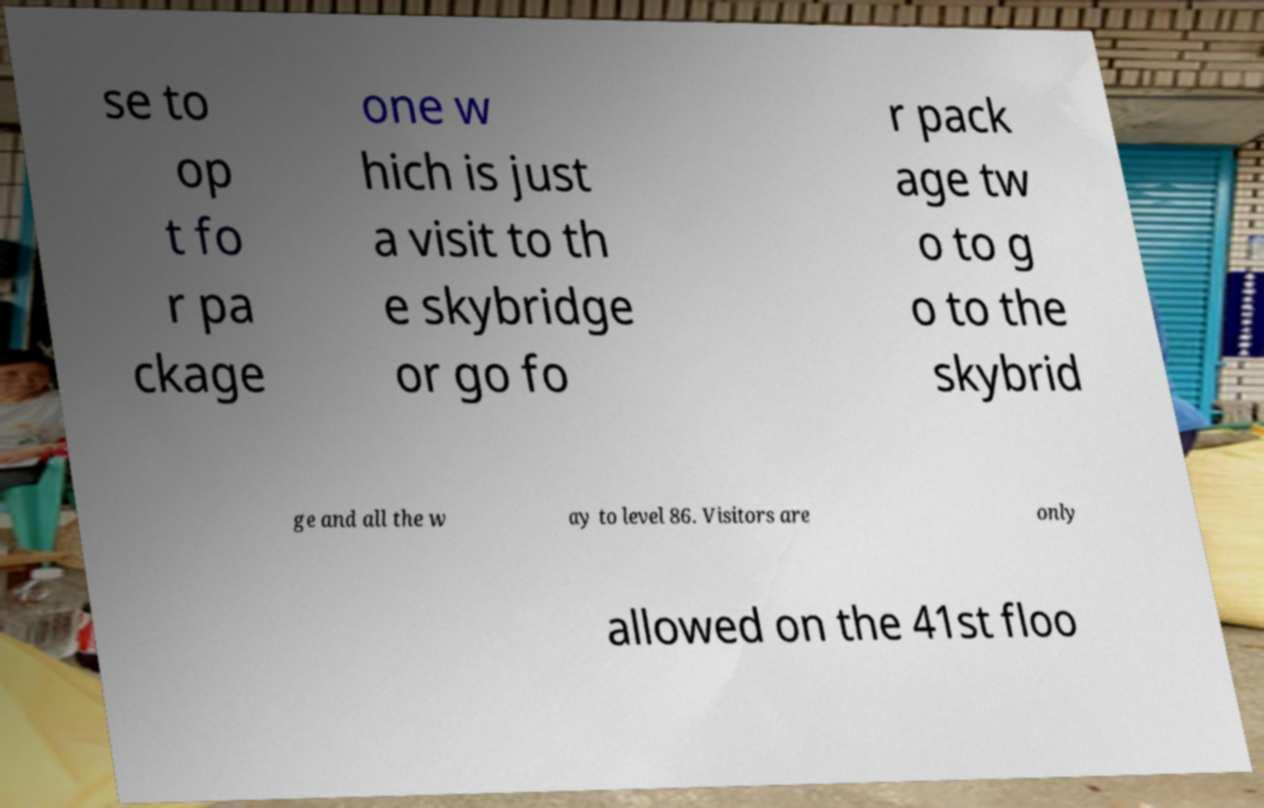I need the written content from this picture converted into text. Can you do that? se to op t fo r pa ckage one w hich is just a visit to th e skybridge or go fo r pack age tw o to g o to the skybrid ge and all the w ay to level 86. Visitors are only allowed on the 41st floo 